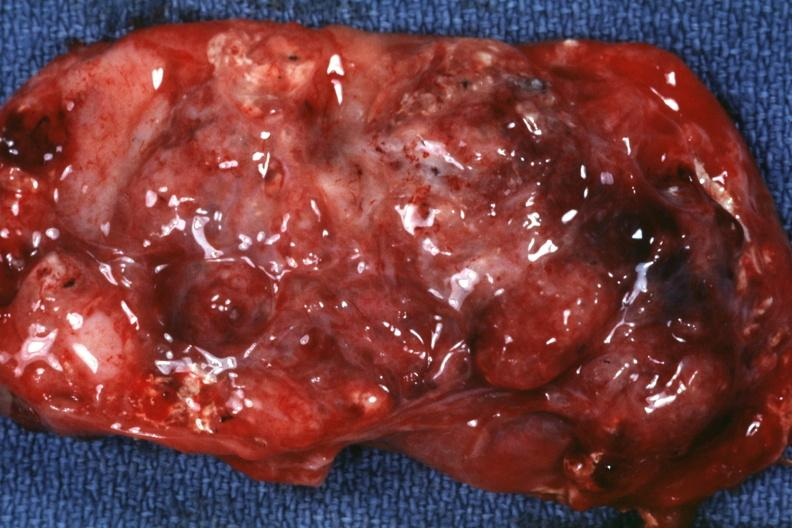what does this image show?
Answer the question using a single word or phrase. Excised tumor mass 